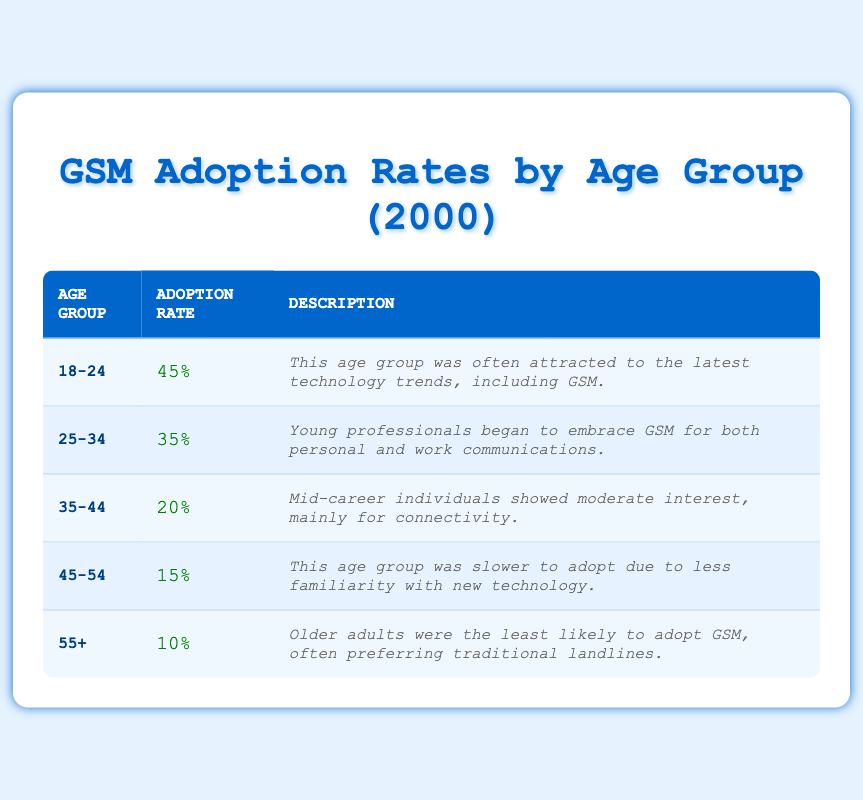What is the adoption rate for the age group 25-34? Looking at the table, the adoption rate for the age group 25-34 is provided directly in the "Adoption Rate" column corresponding to that age group. It states that the adoption rate is 35%.
Answer: 35% Which age group shows the highest GSM adoption rate? The highest adoption rate is listed in the table under the age group 18-24, which is 45%. This is the highest percentage compared to the other age groups.
Answer: 18-24 What is the difference in adoption rates between the age groups 18-24 and 55+? To find the difference, subtract the adoption rate of 55+ (10%) from that of 18-24 (45%). The calculation gives 45% - 10% = 35%.
Answer: 35% Is it true that the adoption rate for those aged 45-54 is higher than that for those aged 35-44? In the table, the adoption rate for the age group 45-54 is 15%, while for 35-44 it is 20%. Since 15% is not higher than 20%, the statement is false.
Answer: No What percentage of users aged 35-44 and 45-54 adopted GSM phones combined? The combined adoption rate can be calculated by adding the two rates together: 20% (for 35-44) + 15% (for 45-54) equals 35%.
Answer: 35% Among the age groups listed, what is the average adoption rate? First, gather the adoption rates: 45%, 35%, 20%, 15%, and 10%. Summing these gives 125%. Then divide by the number of age groups, which is 5. This gives an average of 125% / 5 = 25%.
Answer: 25% Which age group has the lowest adoption rate, and what is that rate? The table indicates that the age group 55+ has the lowest adoption rate at 10%. This is the least percentage compared to all other groups.
Answer: 55+: 10% What can we infer about the user adoption rates based on the information in the table? By reviewing the table, it can be inferred that younger age groups are more inclined to adopt GSM technology, while older age groups show significantly lower adoption rates, indicating a trend of younger users embracing new technology.
Answer: Younger users adopt more What is the total adoption rate for all age groups? To calculate the total, sum all the individual adoption rates: 45% + 35% + 20% + 15% + 10% = 125%. This indicates the cumulative adoption rate across the categorized age groups.
Answer: 125% 